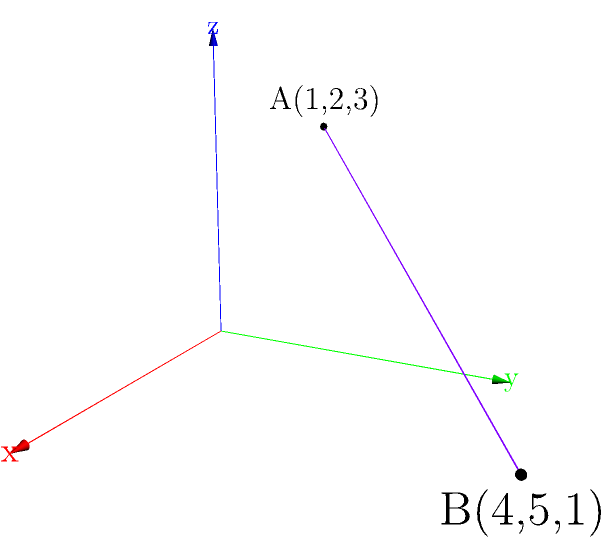In a critical software release, two key data points are represented in 3D space: point A(1,2,3) and point B(4,5,1). To ensure optimal performance and minimize latency in our enterprise operations, we need to calculate the exact distance between these points. Using the distance formula in three-dimensional space, determine the distance between points A and B. To find the distance between two points in 3D space, we use the distance formula:

$$d = \sqrt{(x_2-x_1)^2 + (y_2-y_1)^2 + (z_2-z_1)^2}$$

Where $(x_1,y_1,z_1)$ are the coordinates of the first point and $(x_2,y_2,z_2)$ are the coordinates of the second point.

Given:
Point A: (1,2,3)
Point B: (4,5,1)

Let's substitute these values into the formula:

$$d = \sqrt{(4-1)^2 + (5-2)^2 + (1-3)^2}$$

Now, let's solve step by step:

1) Simplify the expressions inside the parentheses:
   $$d = \sqrt{3^2 + 3^2 + (-2)^2}$$

2) Calculate the squares:
   $$d = \sqrt{9 + 9 + 4}$$

3) Sum the values under the square root:
   $$d = \sqrt{22}$$

4) The square root of 22 cannot be simplified further, so this is our final answer.
Answer: $\sqrt{22}$ 